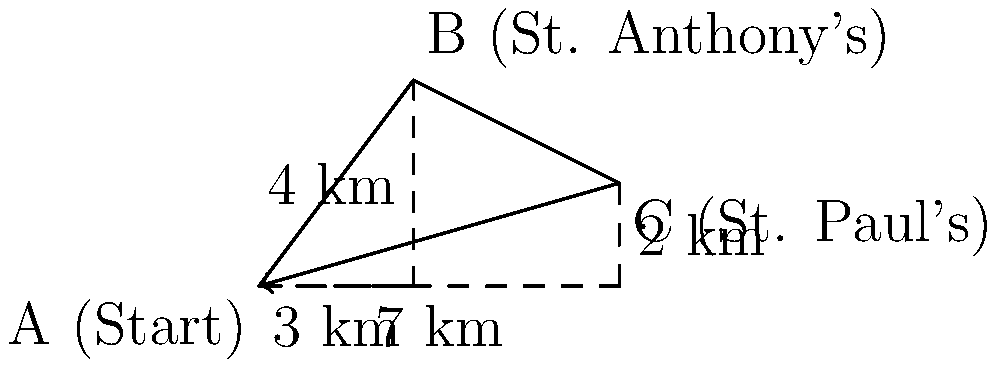A Coptic pilgrim starts at point A and travels to St. Anthony's Monastery at point B, then continues to St. Paul's Monastery at point C. What is the magnitude and direction of the resultant displacement vector from the starting point A to the final destination C? To solve this problem, we'll follow these steps:

1. Identify the displacement vectors:
   - Vector AB: From A to B (St. Anthony's)
   - Vector BC: From B to C (St. Paul's)

2. Calculate vector AB:
   AB = (3, 4)

3. Calculate vector BC:
   BC = (7, 2) - (3, 4) = (4, -2)

4. Find the resultant vector AC by adding AB and BC:
   AC = AB + BC = (3, 4) + (4, -2) = (7, 2)

5. Calculate the magnitude of AC using the Pythagorean theorem:
   |AC| = $$\sqrt{7^2 + 2^2} = \sqrt{53} \approx 7.28$$ km

6. Calculate the direction (angle) of AC with respect to the positive x-axis:
   $$\theta = \tan^{-1}(\frac{2}{7}) \approx 15.95°$$

Therefore, the resultant displacement vector has a magnitude of approximately 7.28 km and direction of about 15.95° above the positive x-axis.
Answer: Magnitude: $$\sqrt{53}$$ km, Direction: $$\tan^{-1}(\frac{2}{7})$$ above x-axis 